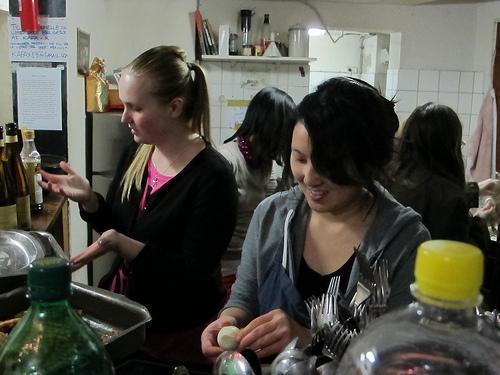How many girls are in the kitchen?
Give a very brief answer. 4. 